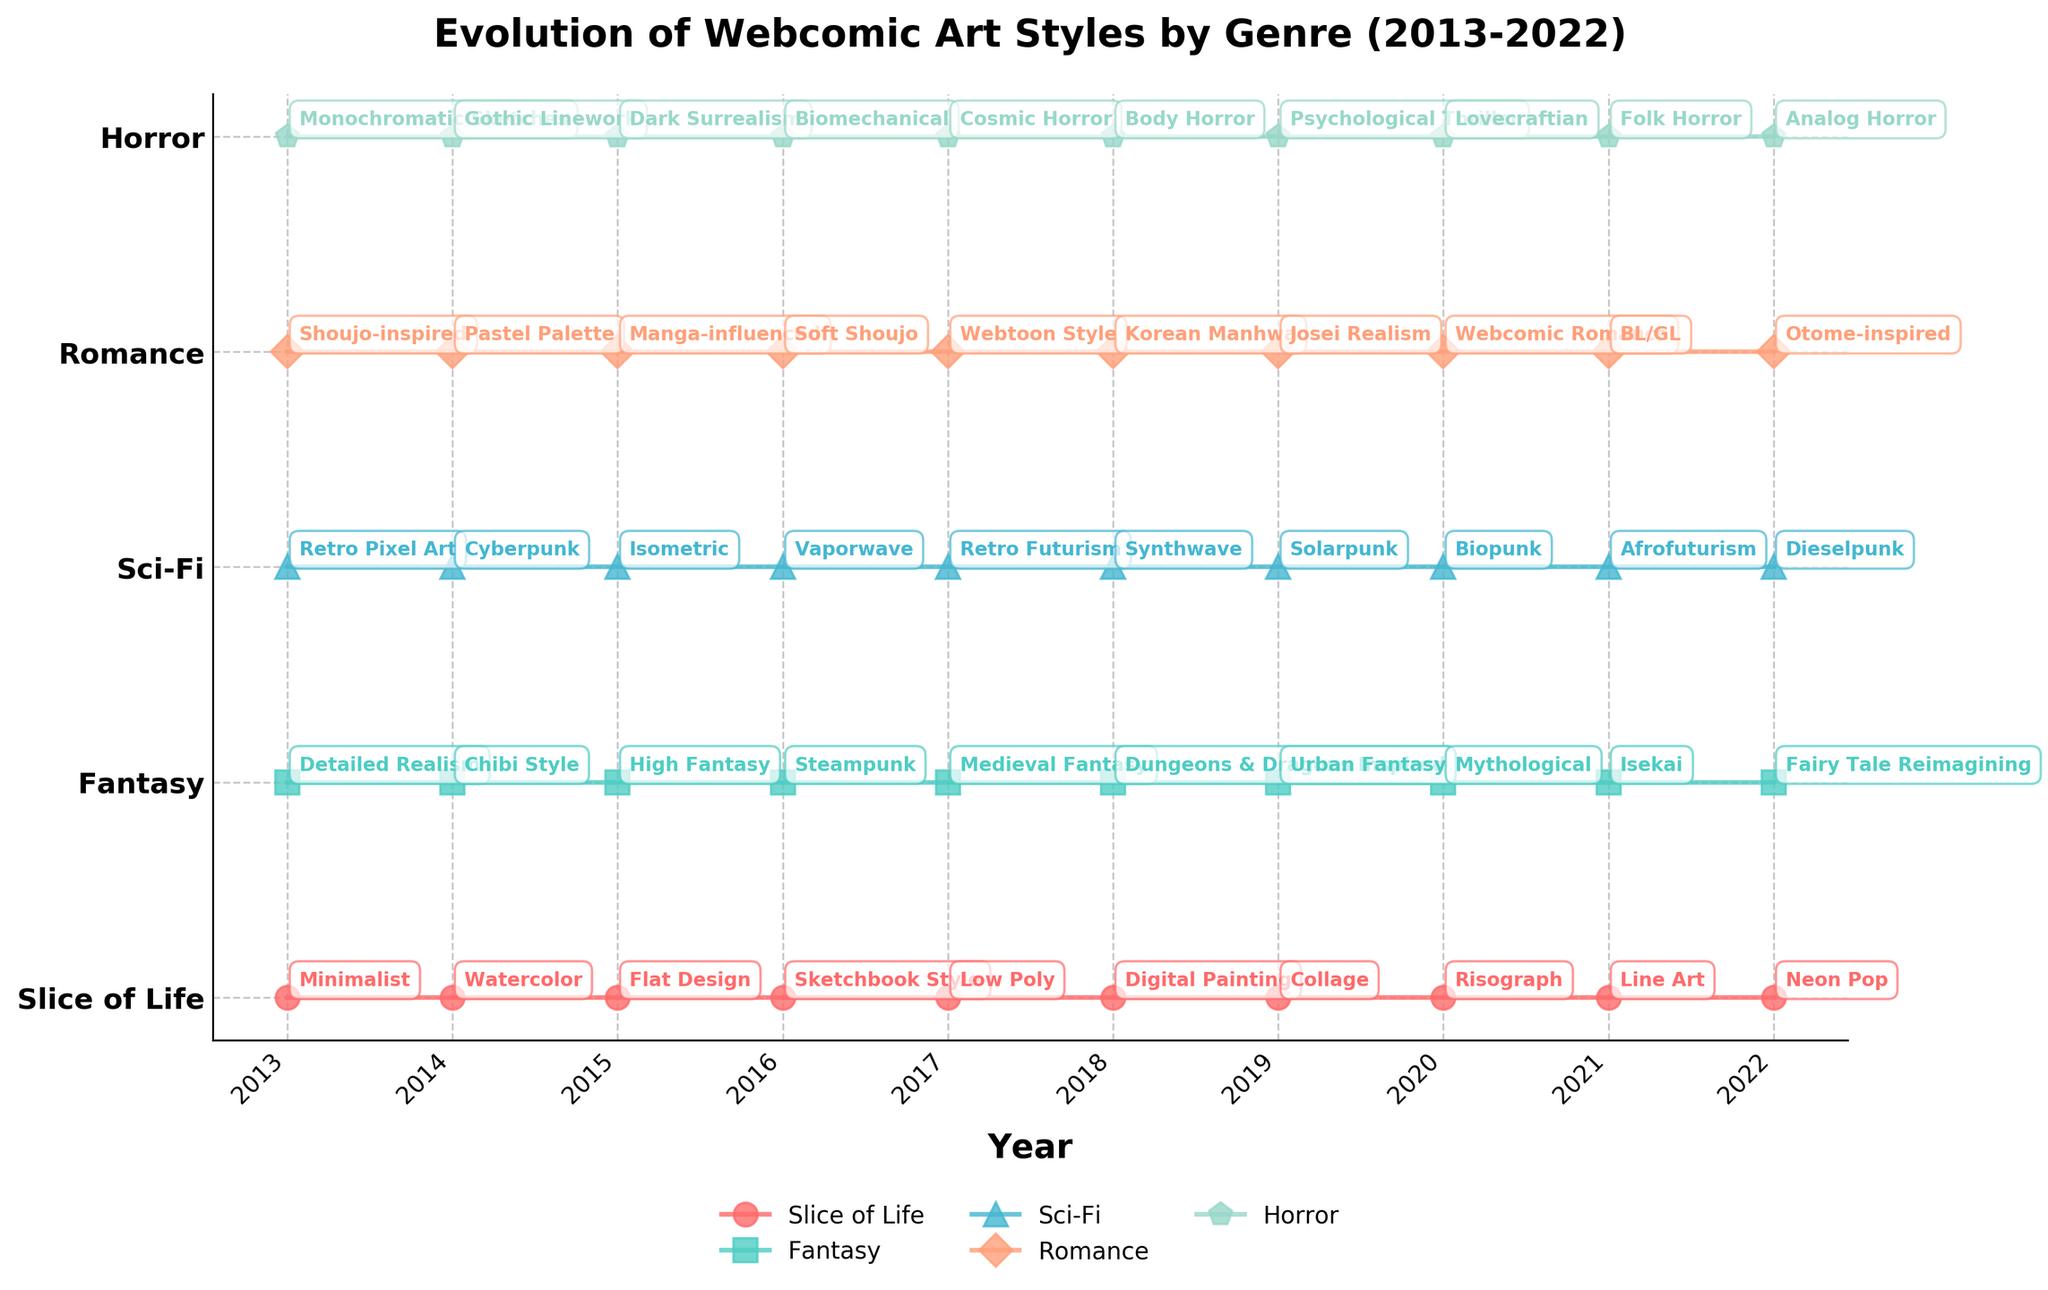What is the prevailing art style for the Fantasy genre in 2016? Look for the "Fantasy" category and identify the art style listed for the year 2016.
Answer: Steampunk Which genres had a change in their art style in 2020 compared to 2019? Check the list of art styles for each genre in 2020 and compare them with the previous year's (2019) styles. The genres that have different styles in these years are the ones that experienced a change.
Answer: All genres What was the most consistent (unchanging) genre in terms of art style throughout the decade? Check for any genre that had the same style across the years 2013 to 2022.
Answer: None (All genres showed changes in art style) In which year did the 'Slice of Life' genre switch to using 'Digital Painting' as an art style? Search for the year where 'Slice of Life' first adopts the 'Digital Painting' style.
Answer: 2018 Do more genres favor retro-themed art styles in the beginning or end of the decade? Identify retro-themed styles and count their occurrences in the initial (2013-2015) and final (2020-2022) years. Retro styles may include: Retro Pixel Art, Retro Futurism, Synthwave, etc. Compare the counts.
Answer: End of the decade Which year saw the highest number of different art styles across all genres? For each year, count the different art styles listed under every genre and identify the year with the highest count.
Answer: 2019 What is the general trend in art styles for the 'Sci-Fi' genre over the decade? Analyze the listed art styles for 'Sci-Fi' from 2013 to 2022, noting any particular themes or shifts. Check if the styles lean towards futuristic or historic elements over time.
Answer: Trend from Retro Pixel Art to Dieselpunk (generally futuristic) How does the prevalence of horror art styles alter between 2013 and 2022? Examine the 'Horror' category and note the differences and descriptive changes in art styles between the two years.
Answer: Transition from Monochromatic Sketches to Analog Horror 